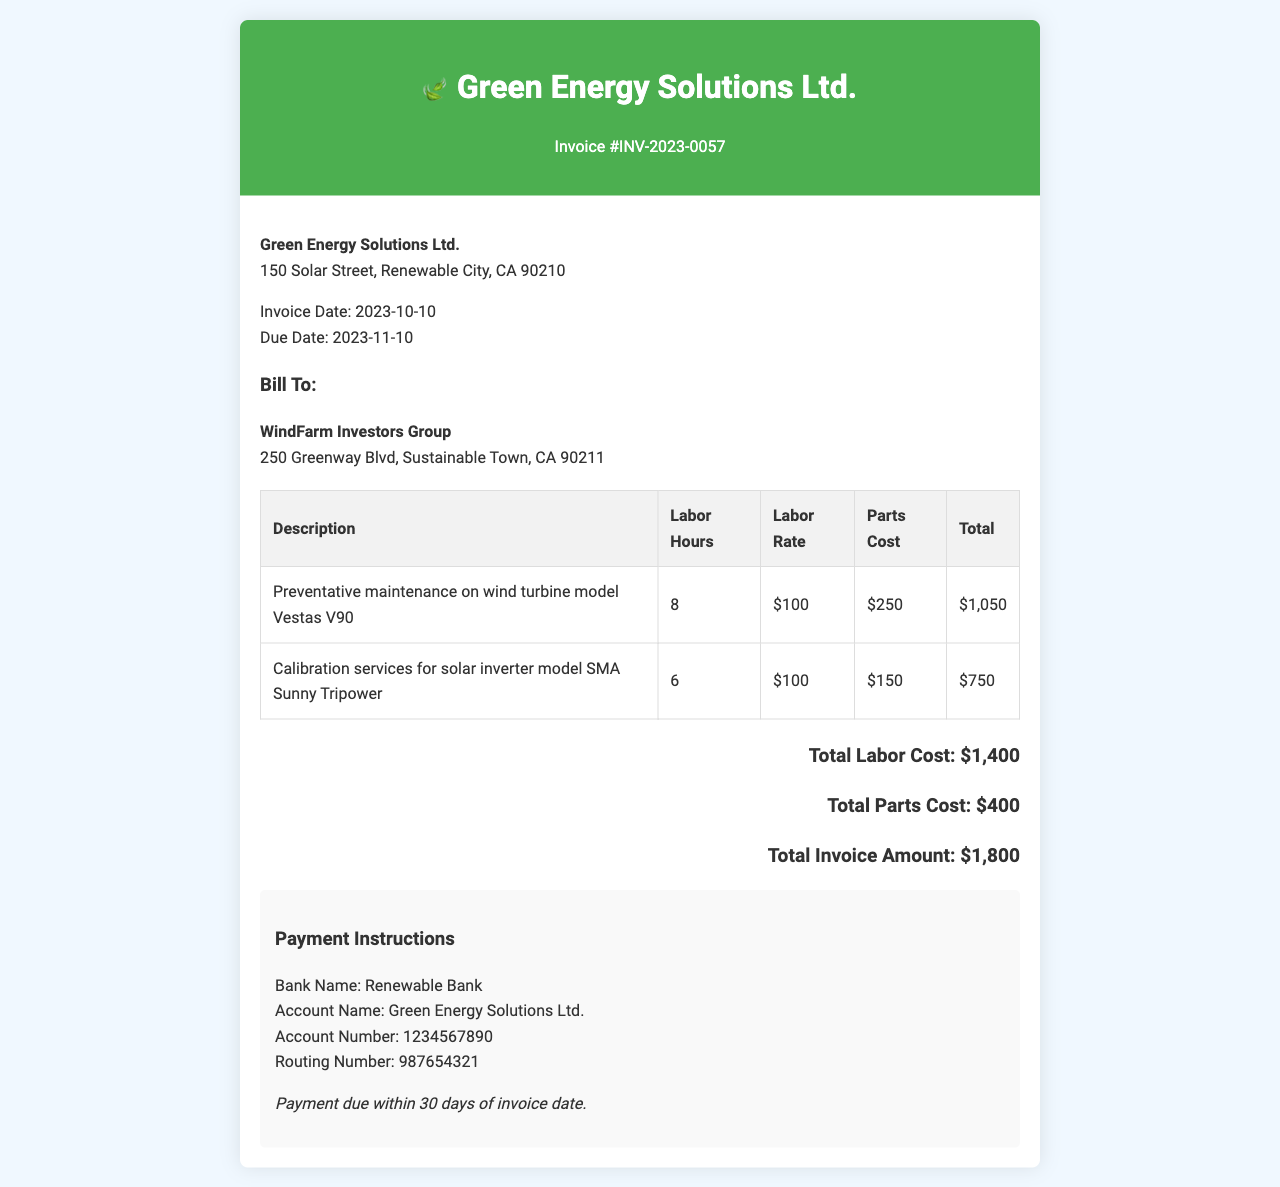What is the invoice number? The invoice number is listed at the top of the document as INV-2023-0057.
Answer: INV-2023-0057 What is the invoice date? The invoice date is provided in the document and is 2023-10-10.
Answer: 2023-10-10 Who is billed for the maintenance services? The billing information includes the customer "WindFarm Investors Group," which is detailed in the document.
Answer: WindFarm Investors Group What is the total invoice amount? The document provides a total invoice amount at the end, which is $1,800.
Answer: $1,800 How many labor hours were charged for the solar inverter calibration? The document specifies that 6 labor hours were charged for the calibration services.
Answer: 6 What is the labor rate per hour? The labor rate per hour is consistently noted as $100 for both tasks in the invoice.
Answer: $100 What is the total parts cost listed? The total parts cost is a cumulative amount stated at the bottom of the invoice, which is $400.
Answer: $400 What type of maintenance service was provided for the wind turbine? The invoice describes the service performed as preventative maintenance, specifically for the wind turbine model Vestas V90.
Answer: Preventative maintenance What are the payment instructions regarding the due date? The document states that payment is due within 30 days of the invoice date, which implies a due date of 2023-11-10.
Answer: 30 days of invoice date 